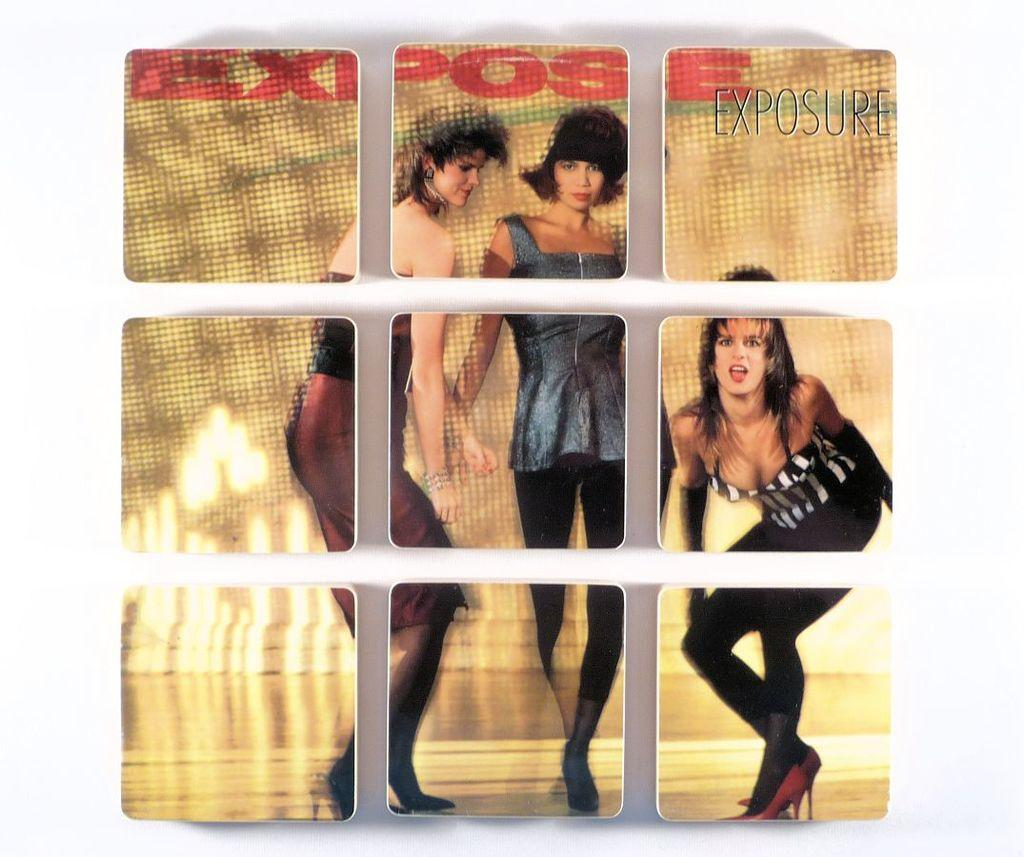How many women are present in the image? There are three women standing in the image. What can be observed about the image itself? The image appears to be edited. What is the color of the surface behind the women? The surface behind the women is cream-colored. What is the color of the background in the image? The background of the image is white. What type of rose can be seen in the image? There is no rose present in the image. What religious symbols can be seen in the image? There are no religious symbols present in the image. 